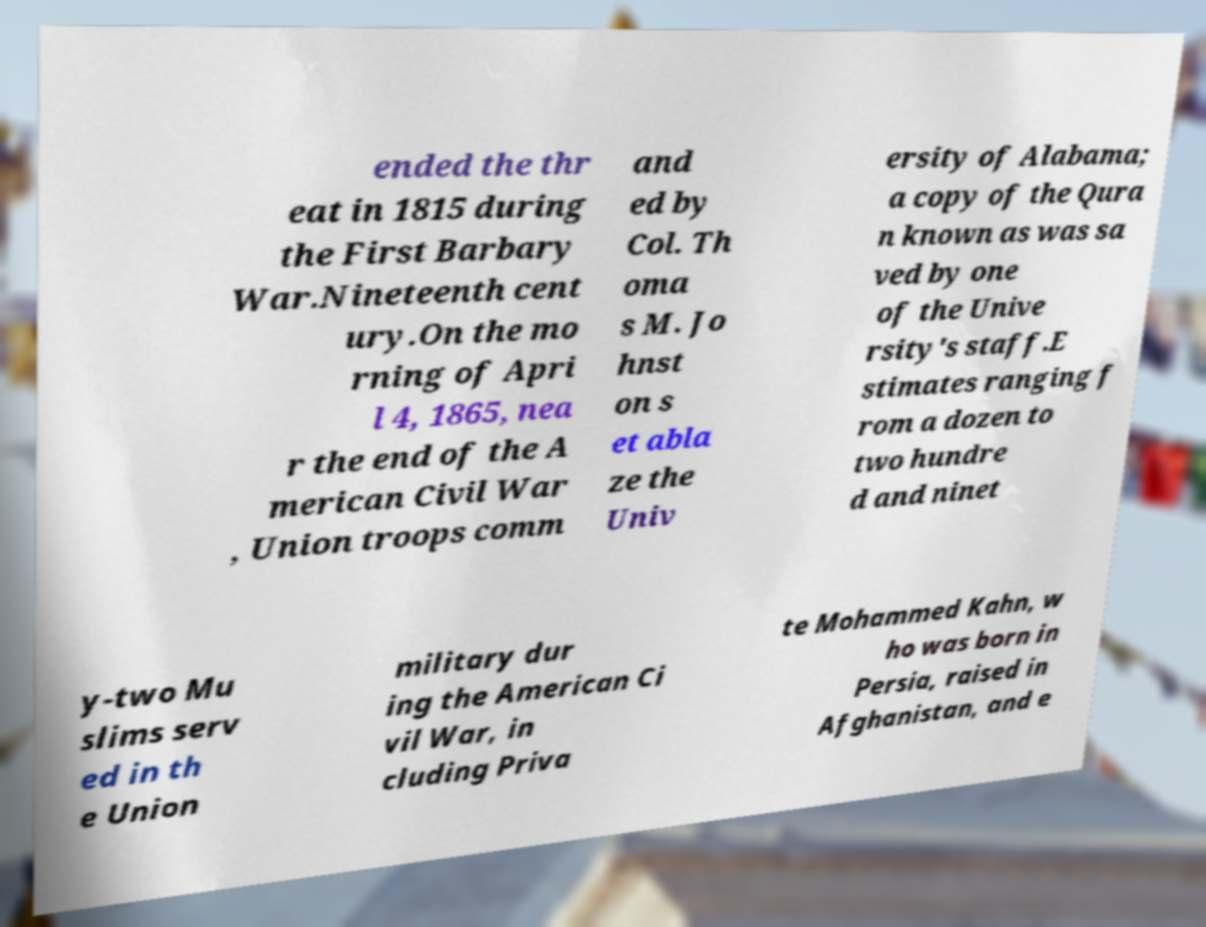What messages or text are displayed in this image? I need them in a readable, typed format. ended the thr eat in 1815 during the First Barbary War.Nineteenth cent ury.On the mo rning of Apri l 4, 1865, nea r the end of the A merican Civil War , Union troops comm and ed by Col. Th oma s M. Jo hnst on s et abla ze the Univ ersity of Alabama; a copy of the Qura n known as was sa ved by one of the Unive rsity's staff.E stimates ranging f rom a dozen to two hundre d and ninet y-two Mu slims serv ed in th e Union military dur ing the American Ci vil War, in cluding Priva te Mohammed Kahn, w ho was born in Persia, raised in Afghanistan, and e 